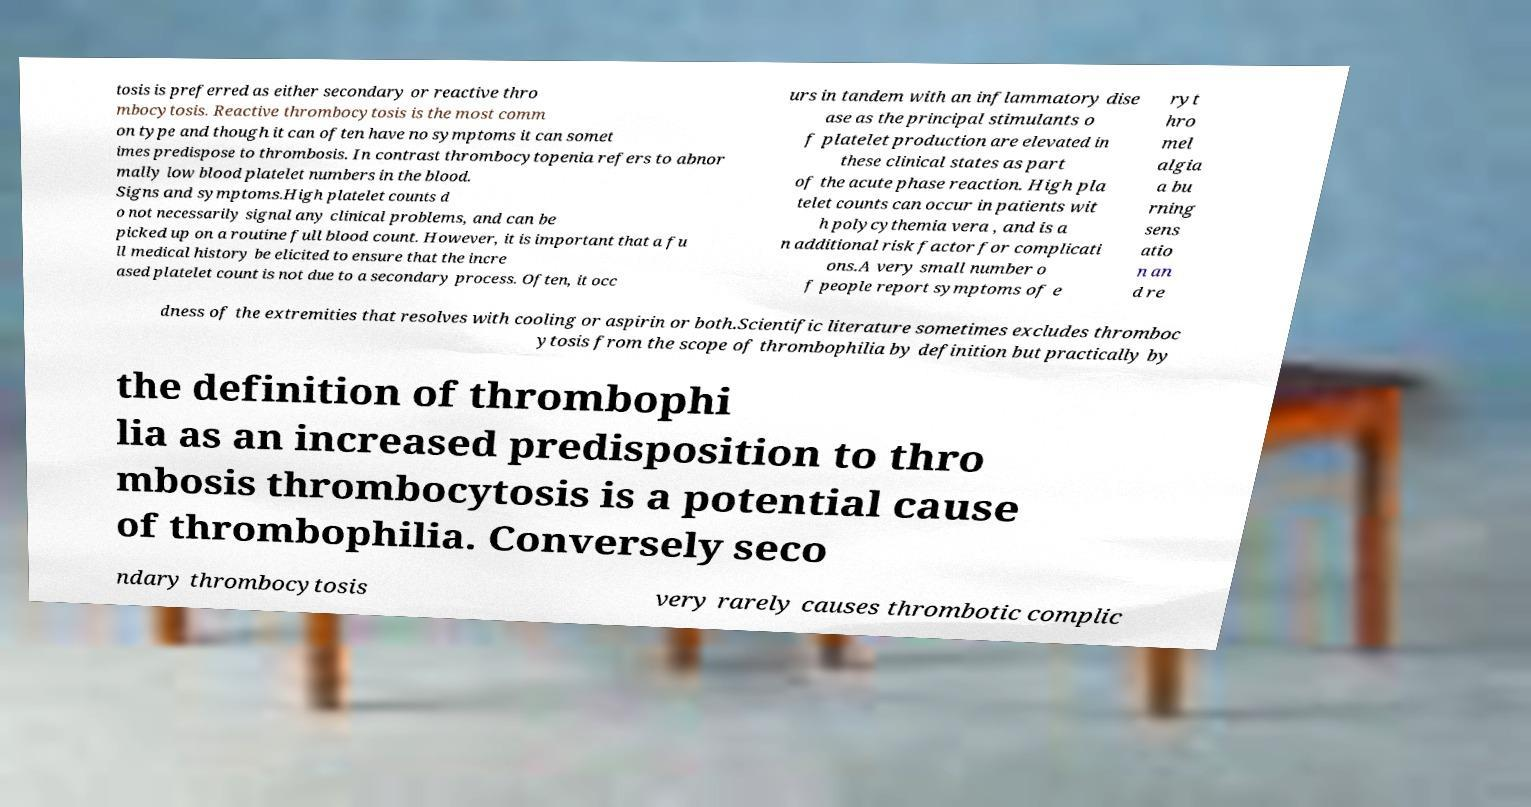For documentation purposes, I need the text within this image transcribed. Could you provide that? tosis is preferred as either secondary or reactive thro mbocytosis. Reactive thrombocytosis is the most comm on type and though it can often have no symptoms it can somet imes predispose to thrombosis. In contrast thrombocytopenia refers to abnor mally low blood platelet numbers in the blood. Signs and symptoms.High platelet counts d o not necessarily signal any clinical problems, and can be picked up on a routine full blood count. However, it is important that a fu ll medical history be elicited to ensure that the incre ased platelet count is not due to a secondary process. Often, it occ urs in tandem with an inflammatory dise ase as the principal stimulants o f platelet production are elevated in these clinical states as part of the acute phase reaction. High pla telet counts can occur in patients wit h polycythemia vera , and is a n additional risk factor for complicati ons.A very small number o f people report symptoms of e ryt hro mel algia a bu rning sens atio n an d re dness of the extremities that resolves with cooling or aspirin or both.Scientific literature sometimes excludes thromboc ytosis from the scope of thrombophilia by definition but practically by the definition of thrombophi lia as an increased predisposition to thro mbosis thrombocytosis is a potential cause of thrombophilia. Conversely seco ndary thrombocytosis very rarely causes thrombotic complic 